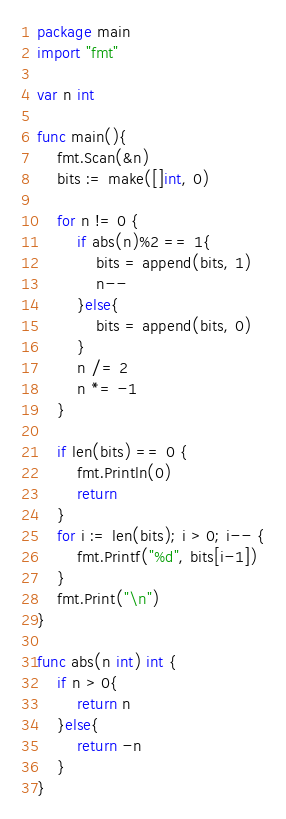Convert code to text. <code><loc_0><loc_0><loc_500><loc_500><_Go_>package main
import "fmt"

var n int
	
func main(){
    fmt.Scan(&n)
    bits := make([]int, 0)
    
    for n != 0 {
        if abs(n)%2 == 1{
            bits = append(bits, 1)
            n--
        }else{
            bits = append(bits, 0)
        }
        n /= 2
        n *= -1
    }
    
    if len(bits) == 0 {
        fmt.Println(0)
        return
    }
    for i := len(bits); i > 0; i-- {
        fmt.Printf("%d", bits[i-1])
    }
    fmt.Print("\n")
}

func abs(n int) int {
    if n > 0{
        return n
    }else{
        return -n
    }
}</code> 